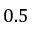Convert formula to latex. <formula><loc_0><loc_0><loc_500><loc_500>0 . 5</formula> 